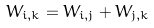Convert formula to latex. <formula><loc_0><loc_0><loc_500><loc_500>W _ { i , k } = W _ { i , j } + W _ { j , k }</formula> 